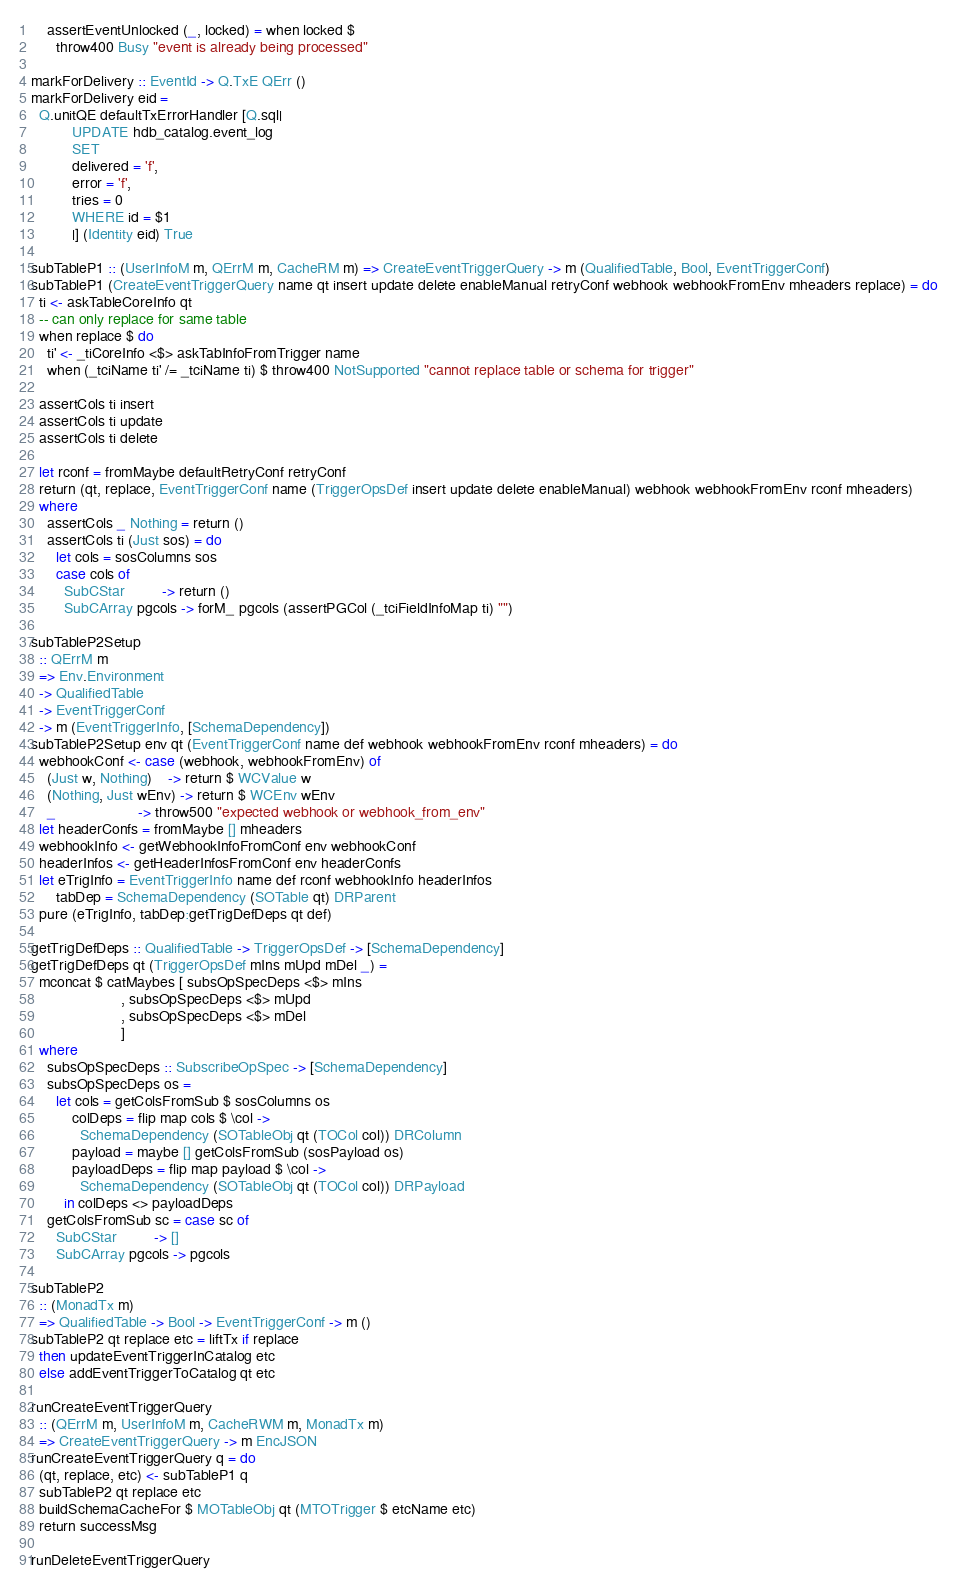Convert code to text. <code><loc_0><loc_0><loc_500><loc_500><_Haskell_>    assertEventUnlocked (_, locked) = when locked $
      throw400 Busy "event is already being processed"

markForDelivery :: EventId -> Q.TxE QErr ()
markForDelivery eid =
  Q.unitQE defaultTxErrorHandler [Q.sql|
          UPDATE hdb_catalog.event_log
          SET
          delivered = 'f',
          error = 'f',
          tries = 0
          WHERE id = $1
          |] (Identity eid) True

subTableP1 :: (UserInfoM m, QErrM m, CacheRM m) => CreateEventTriggerQuery -> m (QualifiedTable, Bool, EventTriggerConf)
subTableP1 (CreateEventTriggerQuery name qt insert update delete enableManual retryConf webhook webhookFromEnv mheaders replace) = do
  ti <- askTableCoreInfo qt
  -- can only replace for same table
  when replace $ do
    ti' <- _tiCoreInfo <$> askTabInfoFromTrigger name
    when (_tciName ti' /= _tciName ti) $ throw400 NotSupported "cannot replace table or schema for trigger"

  assertCols ti insert
  assertCols ti update
  assertCols ti delete

  let rconf = fromMaybe defaultRetryConf retryConf
  return (qt, replace, EventTriggerConf name (TriggerOpsDef insert update delete enableManual) webhook webhookFromEnv rconf mheaders)
  where
    assertCols _ Nothing = return ()
    assertCols ti (Just sos) = do
      let cols = sosColumns sos
      case cols of
        SubCStar         -> return ()
        SubCArray pgcols -> forM_ pgcols (assertPGCol (_tciFieldInfoMap ti) "")

subTableP2Setup
  :: QErrM m
  => Env.Environment
  -> QualifiedTable
  -> EventTriggerConf
  -> m (EventTriggerInfo, [SchemaDependency])
subTableP2Setup env qt (EventTriggerConf name def webhook webhookFromEnv rconf mheaders) = do
  webhookConf <- case (webhook, webhookFromEnv) of
    (Just w, Nothing)    -> return $ WCValue w
    (Nothing, Just wEnv) -> return $ WCEnv wEnv
    _                    -> throw500 "expected webhook or webhook_from_env"
  let headerConfs = fromMaybe [] mheaders
  webhookInfo <- getWebhookInfoFromConf env webhookConf
  headerInfos <- getHeaderInfosFromConf env headerConfs
  let eTrigInfo = EventTriggerInfo name def rconf webhookInfo headerInfos
      tabDep = SchemaDependency (SOTable qt) DRParent
  pure (eTrigInfo, tabDep:getTrigDefDeps qt def)

getTrigDefDeps :: QualifiedTable -> TriggerOpsDef -> [SchemaDependency]
getTrigDefDeps qt (TriggerOpsDef mIns mUpd mDel _) =
  mconcat $ catMaybes [ subsOpSpecDeps <$> mIns
                      , subsOpSpecDeps <$> mUpd
                      , subsOpSpecDeps <$> mDel
                      ]
  where
    subsOpSpecDeps :: SubscribeOpSpec -> [SchemaDependency]
    subsOpSpecDeps os =
      let cols = getColsFromSub $ sosColumns os
          colDeps = flip map cols $ \col ->
            SchemaDependency (SOTableObj qt (TOCol col)) DRColumn
          payload = maybe [] getColsFromSub (sosPayload os)
          payloadDeps = flip map payload $ \col ->
            SchemaDependency (SOTableObj qt (TOCol col)) DRPayload
        in colDeps <> payloadDeps
    getColsFromSub sc = case sc of
      SubCStar         -> []
      SubCArray pgcols -> pgcols

subTableP2
  :: (MonadTx m)
  => QualifiedTable -> Bool -> EventTriggerConf -> m ()
subTableP2 qt replace etc = liftTx if replace
  then updateEventTriggerInCatalog etc
  else addEventTriggerToCatalog qt etc

runCreateEventTriggerQuery
  :: (QErrM m, UserInfoM m, CacheRWM m, MonadTx m)
  => CreateEventTriggerQuery -> m EncJSON
runCreateEventTriggerQuery q = do
  (qt, replace, etc) <- subTableP1 q
  subTableP2 qt replace etc
  buildSchemaCacheFor $ MOTableObj qt (MTOTrigger $ etcName etc)
  return successMsg

runDeleteEventTriggerQuery</code> 